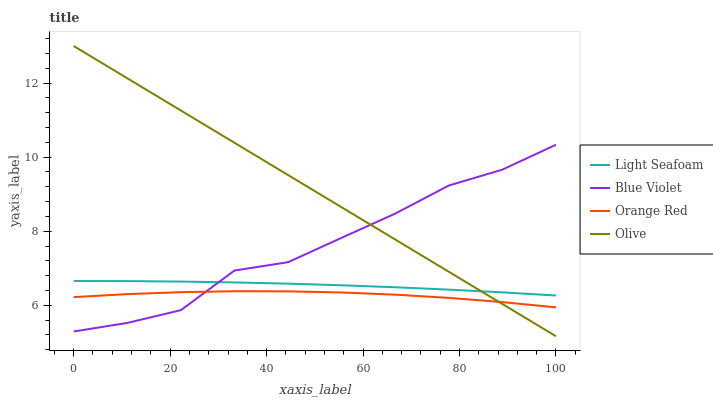Does Orange Red have the minimum area under the curve?
Answer yes or no. Yes. Does Olive have the maximum area under the curve?
Answer yes or no. Yes. Does Light Seafoam have the minimum area under the curve?
Answer yes or no. No. Does Light Seafoam have the maximum area under the curve?
Answer yes or no. No. Is Olive the smoothest?
Answer yes or no. Yes. Is Blue Violet the roughest?
Answer yes or no. Yes. Is Light Seafoam the smoothest?
Answer yes or no. No. Is Light Seafoam the roughest?
Answer yes or no. No. Does Olive have the lowest value?
Answer yes or no. Yes. Does Orange Red have the lowest value?
Answer yes or no. No. Does Olive have the highest value?
Answer yes or no. Yes. Does Light Seafoam have the highest value?
Answer yes or no. No. Is Orange Red less than Light Seafoam?
Answer yes or no. Yes. Is Light Seafoam greater than Orange Red?
Answer yes or no. Yes. Does Light Seafoam intersect Blue Violet?
Answer yes or no. Yes. Is Light Seafoam less than Blue Violet?
Answer yes or no. No. Is Light Seafoam greater than Blue Violet?
Answer yes or no. No. Does Orange Red intersect Light Seafoam?
Answer yes or no. No. 